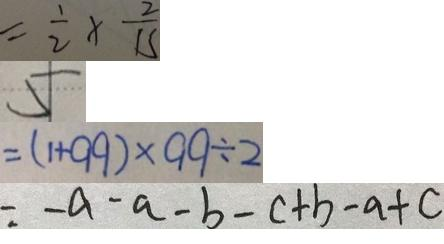Convert formula to latex. <formula><loc_0><loc_0><loc_500><loc_500>= \frac { 1 } { 2 } \times \frac { 2 } { 1 5 } 
 5 
 = ( 1 + 9 9 ) \times 9 9 \div 2 
 = - a - a - b - c + b - a + c</formula> 